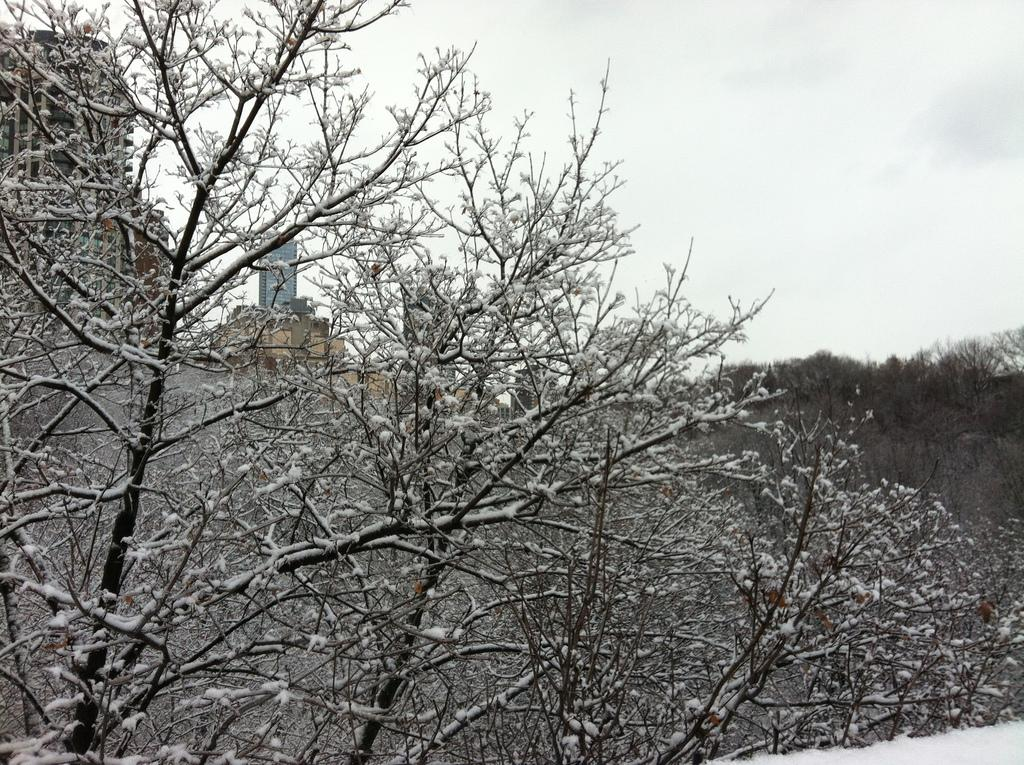What type of weather is suggested by the presence of snow in the image? The presence of snow suggests cold weather in the image. What can be seen in the background of the image? There are trees and buildings in the background of the image. What is visible in the sky in the background of the image? Clouds are visible in the sky in the background of the image. How is the straw distributed among the animals in the image? There is no straw or animals present in the image; it features snow on bare trees and buildings in the background. 